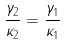Convert formula to latex. <formula><loc_0><loc_0><loc_500><loc_500>\frac { \gamma _ { 2 } } { \kappa _ { 2 } } = \frac { \gamma _ { 1 } } { \kappa _ { 1 } }</formula> 